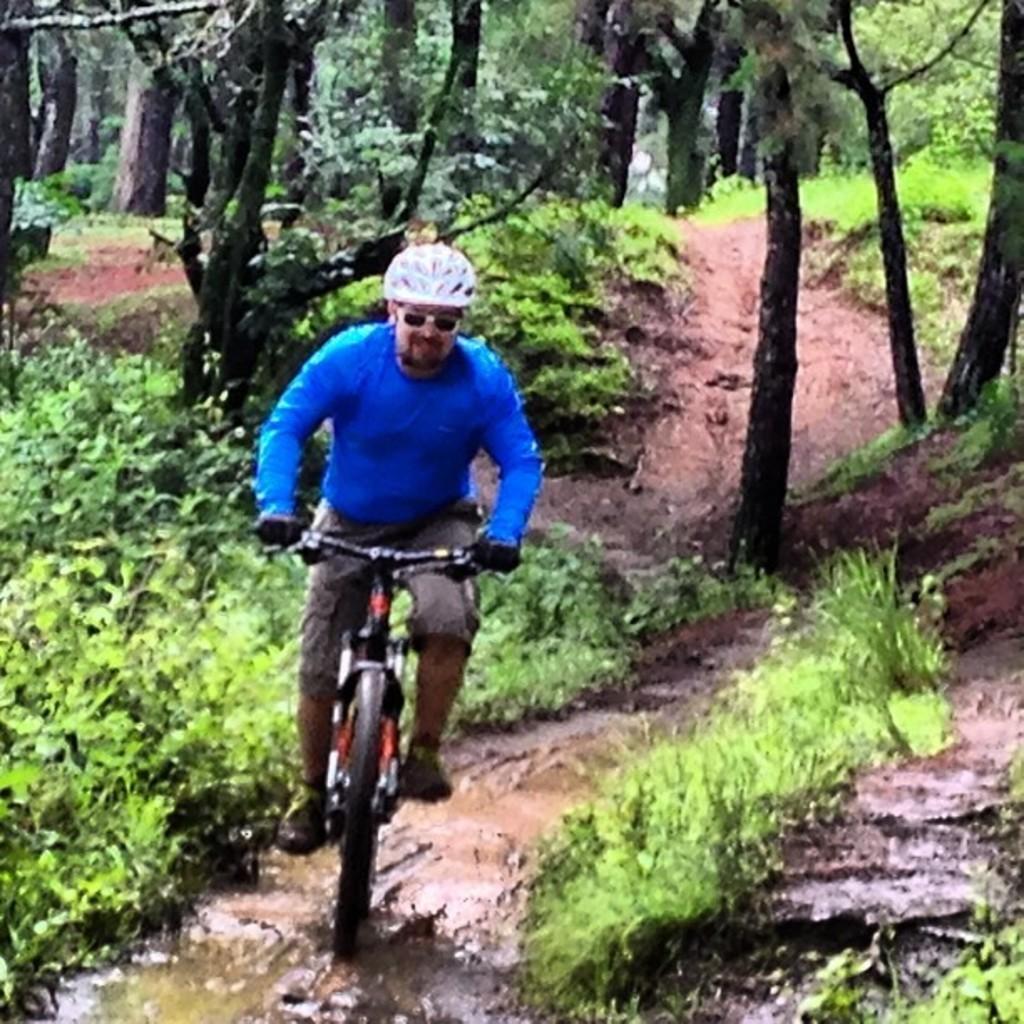Could you give a brief overview of what you see in this image? In the center of the image there is a person riding a bicycle wearing a helmet. At the bottom of the image there is mud,grass. In the background of the image there are trees. 